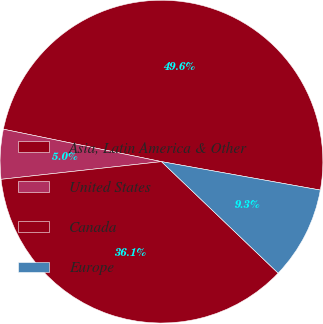Convert chart to OTSL. <chart><loc_0><loc_0><loc_500><loc_500><pie_chart><fcel>Asia, Latin America & Other<fcel>United States<fcel>Canada<fcel>Europe<nl><fcel>49.6%<fcel>4.97%<fcel>36.11%<fcel>9.32%<nl></chart> 